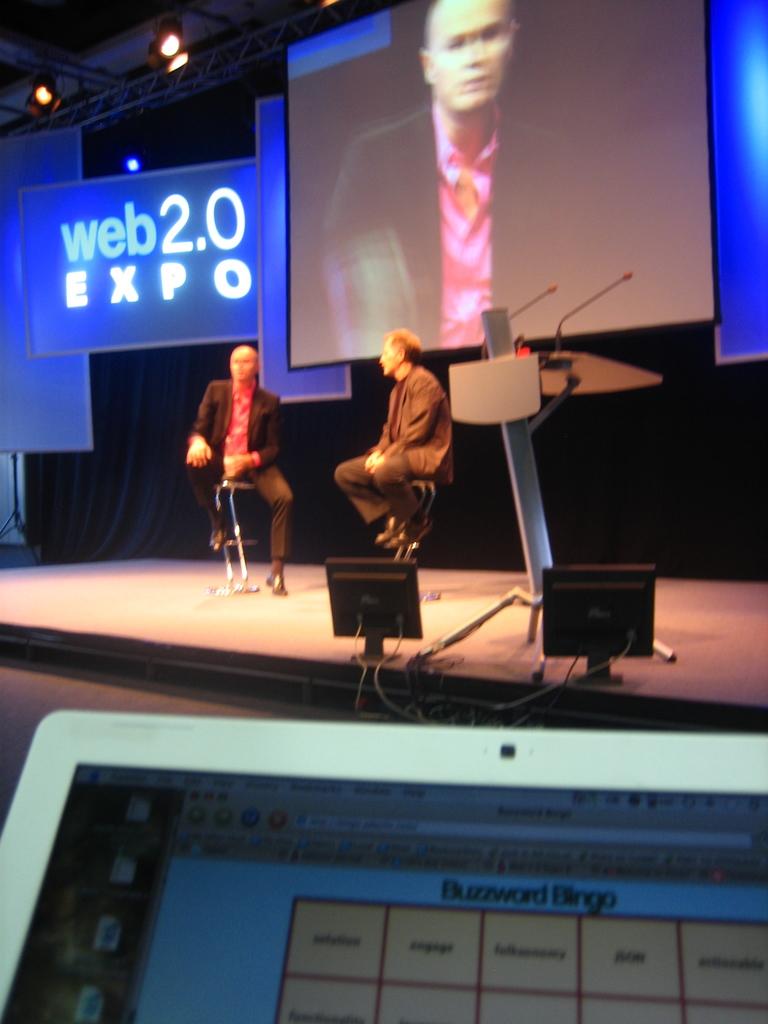What sort of expo is it?
Make the answer very short. Web 2.0. What game is on the ipad?
Offer a terse response. Buzzword bingo. 